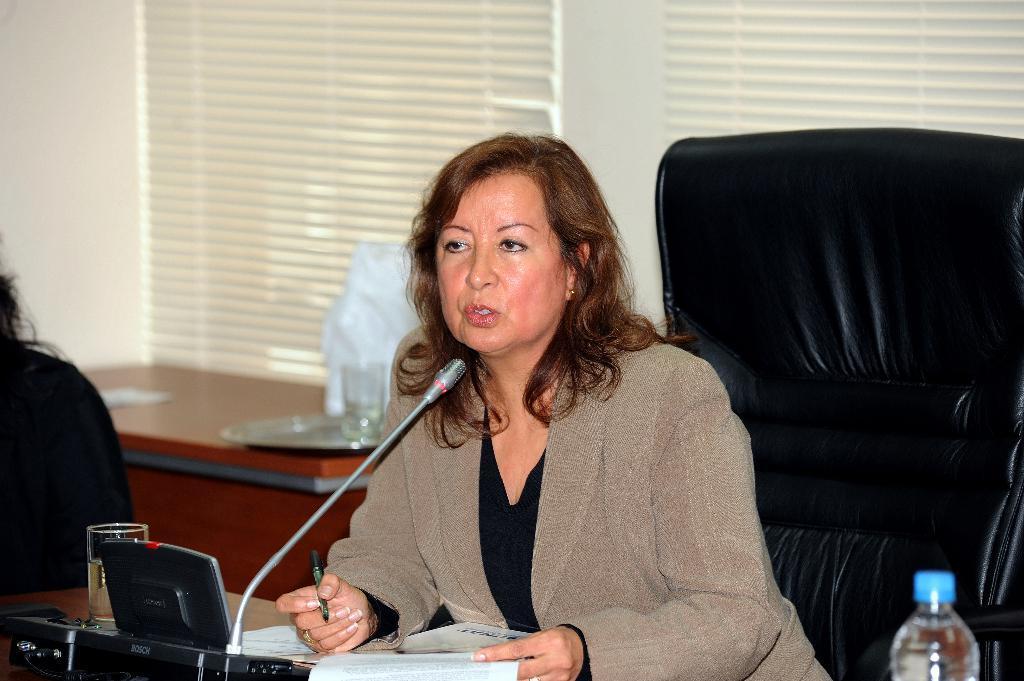Describe this image in one or two sentences. In this picture we can see a woman sitting on the chair. This is the mike. And she is holding a pen with her hand. These are the papers. And there is a bottle. On the background we can see a wall. This is the plate on the table. And this is the curtain. 